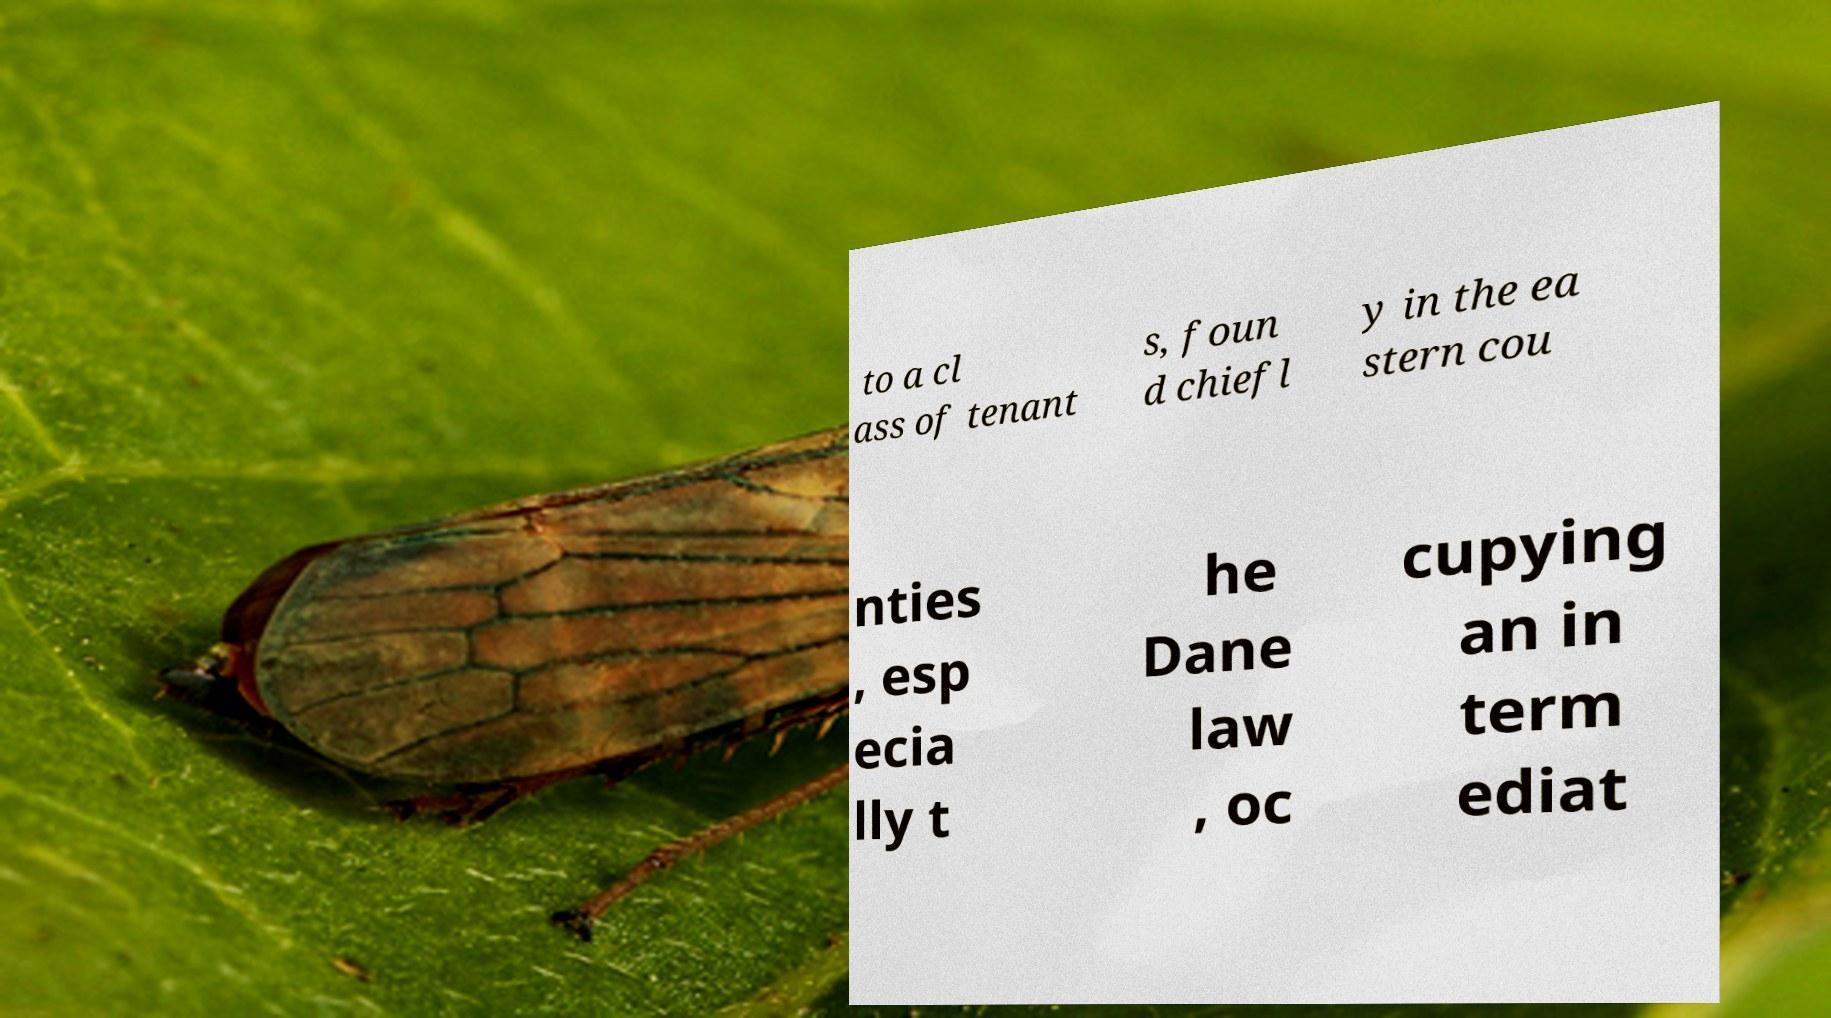For documentation purposes, I need the text within this image transcribed. Could you provide that? to a cl ass of tenant s, foun d chiefl y in the ea stern cou nties , esp ecia lly t he Dane law , oc cupying an in term ediat 